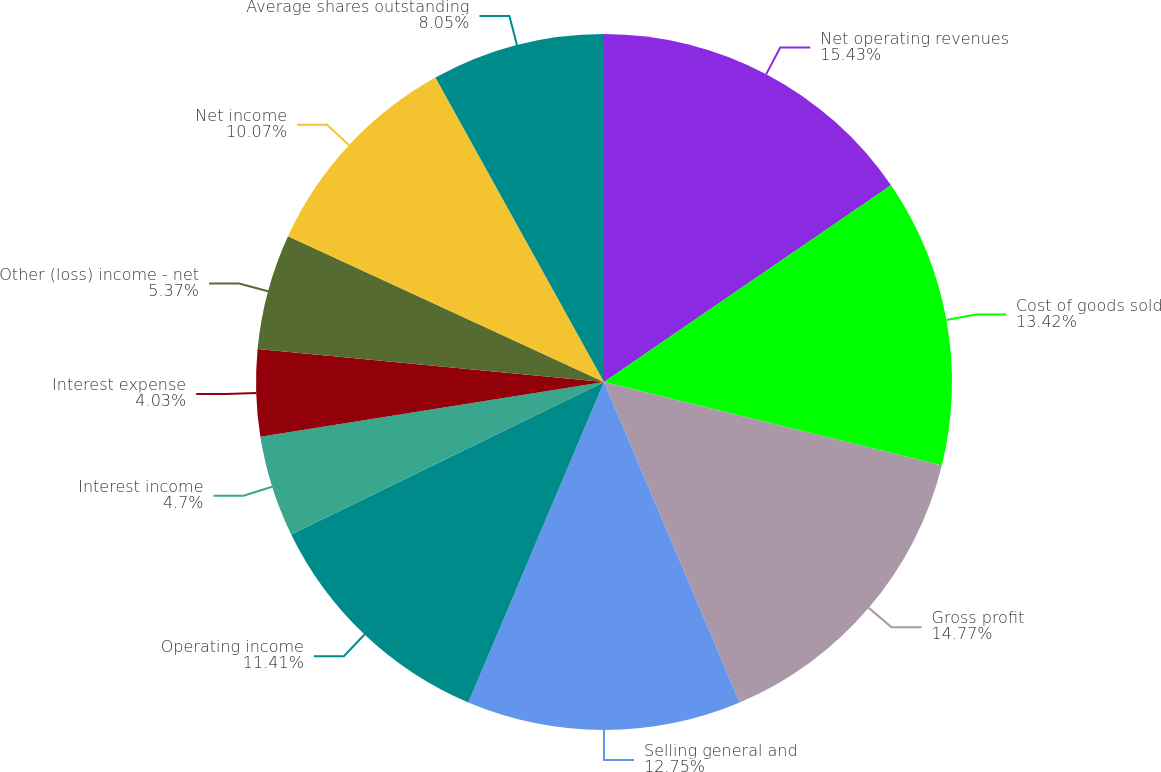<chart> <loc_0><loc_0><loc_500><loc_500><pie_chart><fcel>Net operating revenues<fcel>Cost of goods sold<fcel>Gross profit<fcel>Selling general and<fcel>Operating income<fcel>Interest income<fcel>Interest expense<fcel>Other (loss) income - net<fcel>Net income<fcel>Average shares outstanding<nl><fcel>15.44%<fcel>13.42%<fcel>14.77%<fcel>12.75%<fcel>11.41%<fcel>4.7%<fcel>4.03%<fcel>5.37%<fcel>10.07%<fcel>8.05%<nl></chart> 